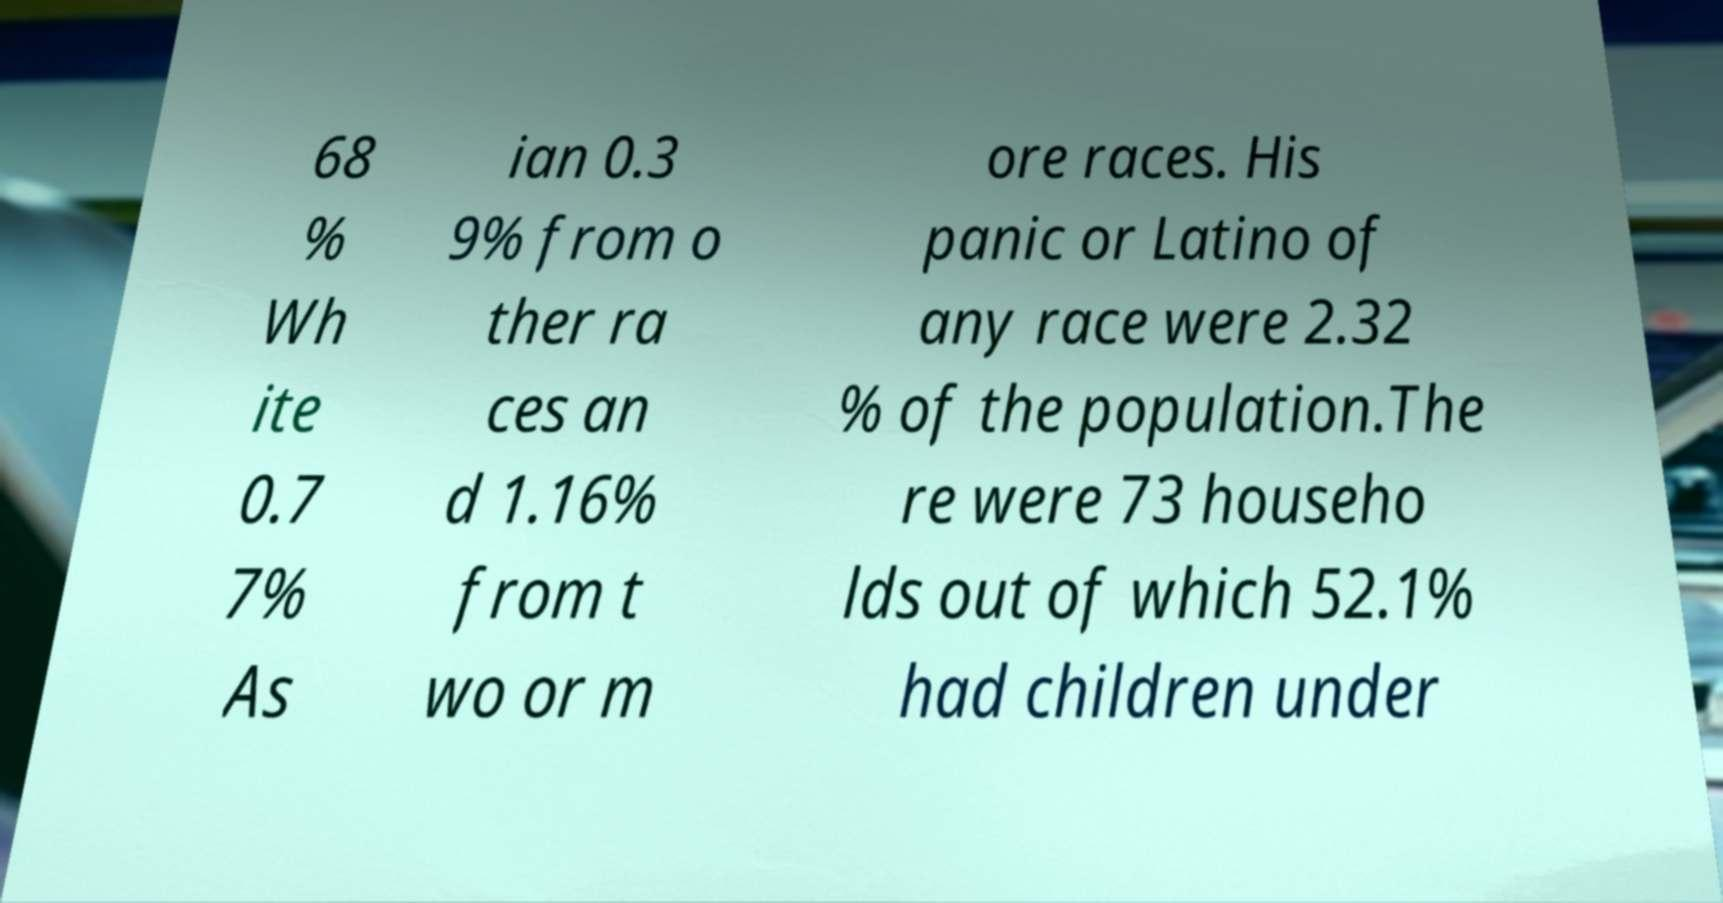For documentation purposes, I need the text within this image transcribed. Could you provide that? 68 % Wh ite 0.7 7% As ian 0.3 9% from o ther ra ces an d 1.16% from t wo or m ore races. His panic or Latino of any race were 2.32 % of the population.The re were 73 househo lds out of which 52.1% had children under 